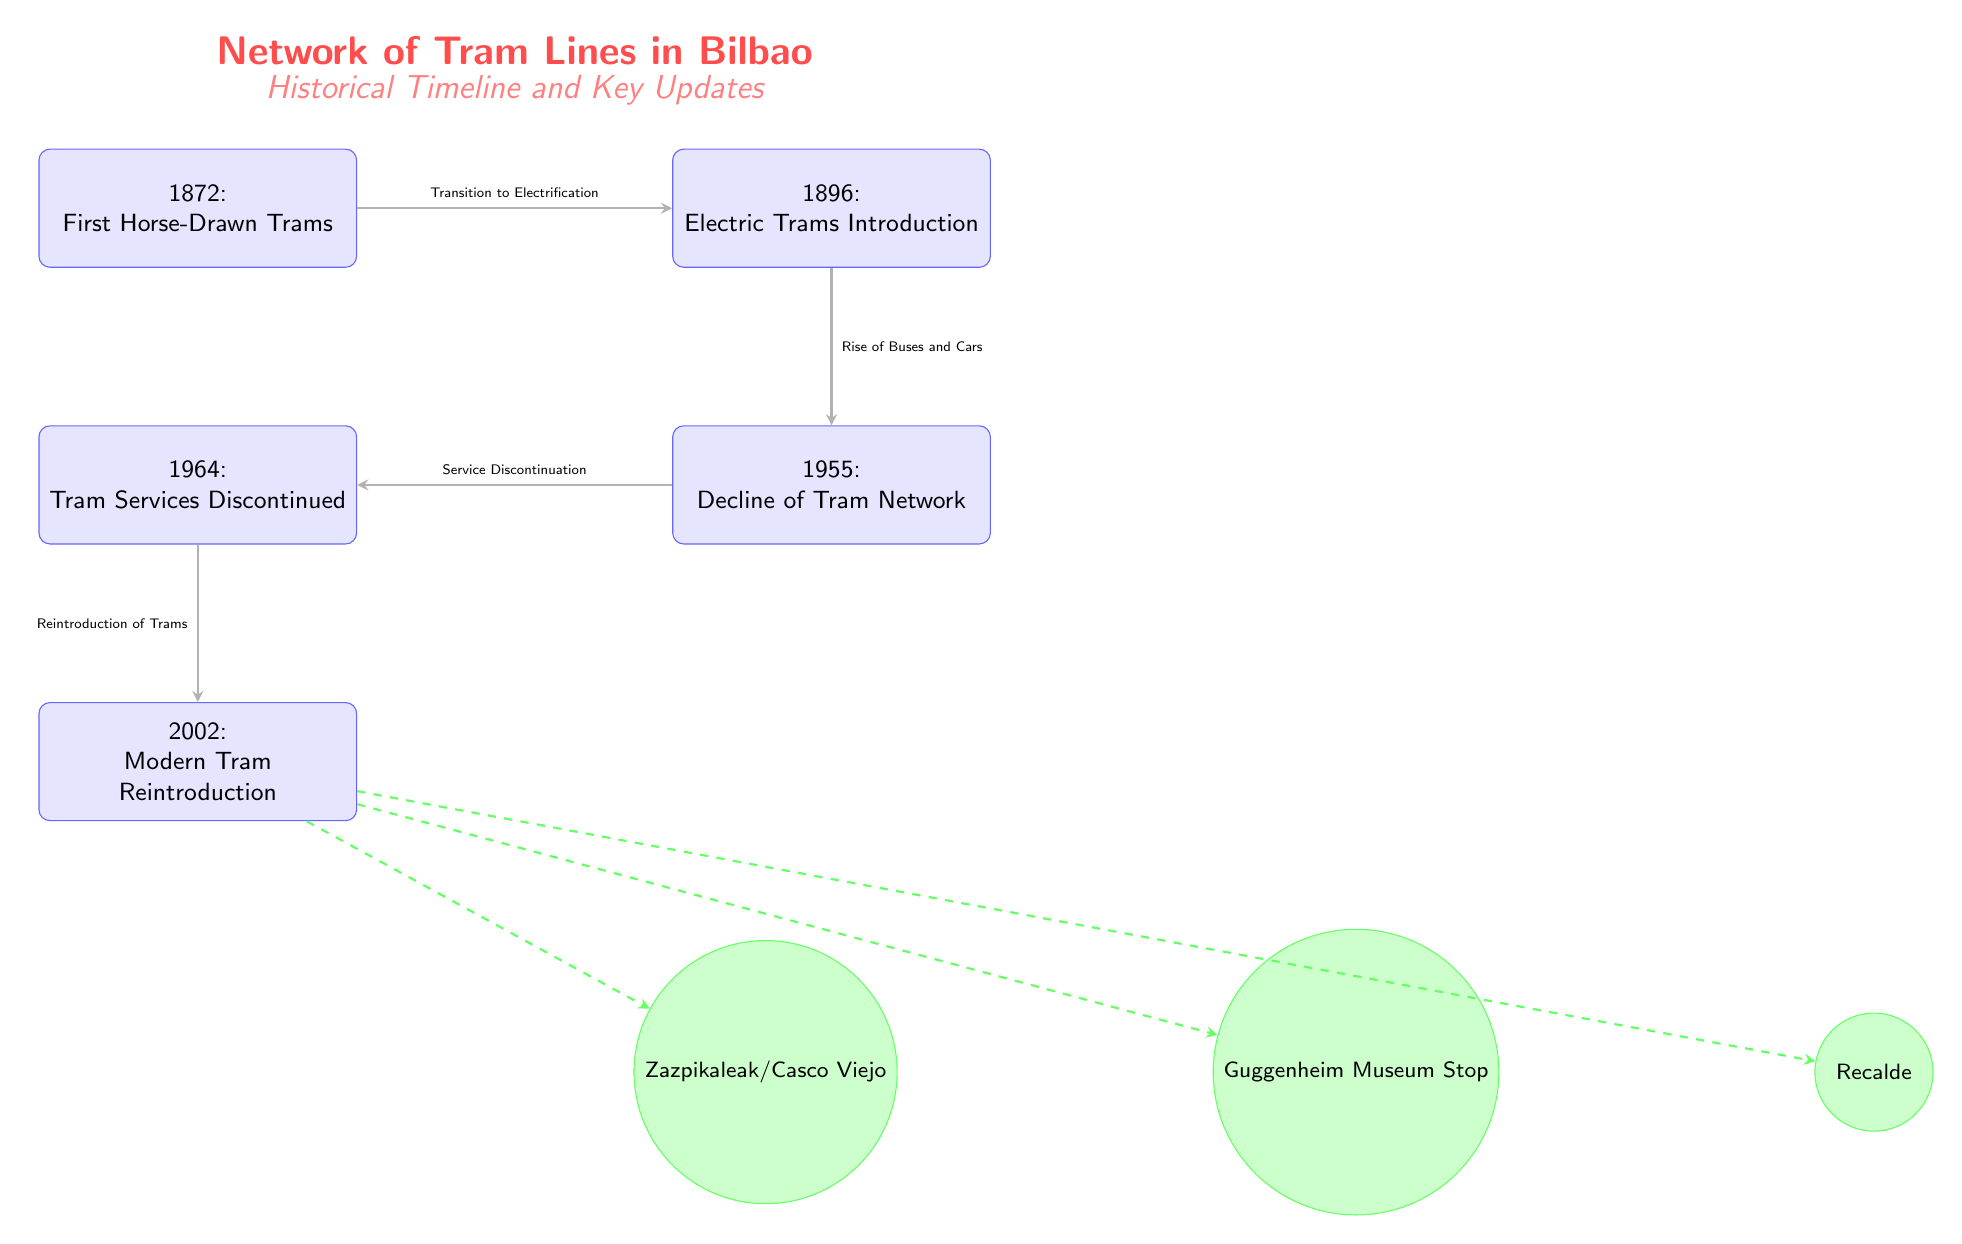What year did the first horse-drawn trams begin operation in Bilbao? The diagram indicates the first horse-drawn trams started in 1872, as denoted in the first event node.
Answer: 1872 What major transportation innovation was introduced in 1896? According to the diagram, 1896 marks the introduction of electric trams, which is detailed in the second event node.
Answer: Electric Trams What significant change occurred in 1964 regarding tram services? The diagram states that in 1964, tram services were discontinued, as shown in the fourth event node.
Answer: Discontinued Which event marks the decline of the tram network? The event representing the decline of the tram network is from 1955, indicated in the third event node.
Answer: Decline of Tram Network How many modern tram stops are shown in the diagram? The diagram depicts three modern tram stops connected to the reintroduction of trams in 2002. Therefore, the count of stops is obtained by reviewing the stop nodes below the fifth event node.
Answer: 3 What was a direct consequence of the introduction of electric trams? According to the arrowed connection in the diagram, the introduction of electric trams in 1896 led to the rise of buses and cars, as marked by the relationship to the next event node in the timeline.
Answer: Rise of Buses and Cars What type of connection is shown from the 2002 node to modern tram stops? The connections from the 2002 modern tram reintroduction to modern tram stops are represented as dashed arrows, indicating an indirect relationship. This is distinct from the solid connections previously noted in other events.
Answer: Dashed Connections Which event represents a revival in the tram services? The diagram indicates that the modern tram reintroduction in 2002 is the event that signifies the revival of tram services after a period of discontinuation. This is specified in the fifth event node.
Answer: Modern Tram Reintroduction 